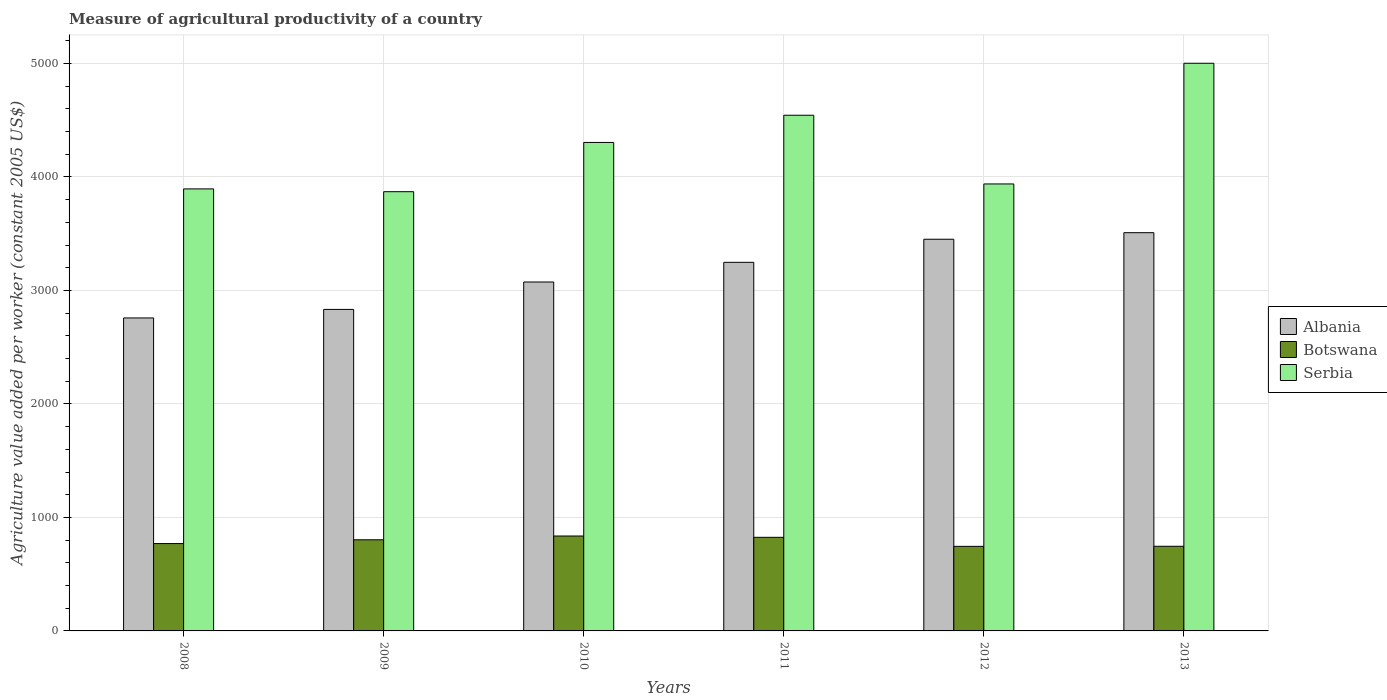How many different coloured bars are there?
Give a very brief answer. 3. How many groups of bars are there?
Provide a succinct answer. 6. Are the number of bars per tick equal to the number of legend labels?
Your answer should be very brief. Yes. How many bars are there on the 4th tick from the right?
Make the answer very short. 3. What is the label of the 2nd group of bars from the left?
Your response must be concise. 2009. What is the measure of agricultural productivity in Botswana in 2008?
Keep it short and to the point. 769.66. Across all years, what is the maximum measure of agricultural productivity in Botswana?
Your answer should be very brief. 836.26. Across all years, what is the minimum measure of agricultural productivity in Botswana?
Your response must be concise. 745.1. What is the total measure of agricultural productivity in Serbia in the graph?
Your response must be concise. 2.56e+04. What is the difference between the measure of agricultural productivity in Albania in 2009 and that in 2013?
Your answer should be compact. -676.02. What is the difference between the measure of agricultural productivity in Serbia in 2011 and the measure of agricultural productivity in Albania in 2013?
Give a very brief answer. 1034.83. What is the average measure of agricultural productivity in Botswana per year?
Provide a short and direct response. 787.42. In the year 2011, what is the difference between the measure of agricultural productivity in Albania and measure of agricultural productivity in Serbia?
Offer a very short reply. -1296.13. In how many years, is the measure of agricultural productivity in Botswana greater than 3000 US$?
Keep it short and to the point. 0. What is the ratio of the measure of agricultural productivity in Albania in 2011 to that in 2012?
Your answer should be very brief. 0.94. Is the difference between the measure of agricultural productivity in Albania in 2009 and 2013 greater than the difference between the measure of agricultural productivity in Serbia in 2009 and 2013?
Make the answer very short. Yes. What is the difference between the highest and the second highest measure of agricultural productivity in Serbia?
Offer a terse response. 457.96. What is the difference between the highest and the lowest measure of agricultural productivity in Botswana?
Give a very brief answer. 91.16. Is the sum of the measure of agricultural productivity in Albania in 2012 and 2013 greater than the maximum measure of agricultural productivity in Serbia across all years?
Give a very brief answer. Yes. What does the 2nd bar from the left in 2012 represents?
Keep it short and to the point. Botswana. What does the 3rd bar from the right in 2011 represents?
Your answer should be very brief. Albania. How many bars are there?
Provide a succinct answer. 18. How many years are there in the graph?
Ensure brevity in your answer.  6. Are the values on the major ticks of Y-axis written in scientific E-notation?
Ensure brevity in your answer.  No. Does the graph contain any zero values?
Ensure brevity in your answer.  No. Does the graph contain grids?
Provide a succinct answer. Yes. Where does the legend appear in the graph?
Give a very brief answer. Center right. How many legend labels are there?
Your answer should be very brief. 3. What is the title of the graph?
Your response must be concise. Measure of agricultural productivity of a country. What is the label or title of the Y-axis?
Your answer should be very brief. Agriculture value added per worker (constant 2005 US$). What is the Agriculture value added per worker (constant 2005 US$) in Albania in 2008?
Your answer should be compact. 2757.6. What is the Agriculture value added per worker (constant 2005 US$) in Botswana in 2008?
Make the answer very short. 769.66. What is the Agriculture value added per worker (constant 2005 US$) in Serbia in 2008?
Your response must be concise. 3894.62. What is the Agriculture value added per worker (constant 2005 US$) of Albania in 2009?
Provide a short and direct response. 2832.81. What is the Agriculture value added per worker (constant 2005 US$) in Botswana in 2009?
Your answer should be compact. 802.96. What is the Agriculture value added per worker (constant 2005 US$) of Serbia in 2009?
Provide a short and direct response. 3870.01. What is the Agriculture value added per worker (constant 2005 US$) of Albania in 2010?
Keep it short and to the point. 3074.35. What is the Agriculture value added per worker (constant 2005 US$) of Botswana in 2010?
Your response must be concise. 836.26. What is the Agriculture value added per worker (constant 2005 US$) in Serbia in 2010?
Your answer should be very brief. 4303.98. What is the Agriculture value added per worker (constant 2005 US$) in Albania in 2011?
Make the answer very short. 3247.53. What is the Agriculture value added per worker (constant 2005 US$) in Botswana in 2011?
Keep it short and to the point. 824.72. What is the Agriculture value added per worker (constant 2005 US$) of Serbia in 2011?
Offer a very short reply. 4543.67. What is the Agriculture value added per worker (constant 2005 US$) in Albania in 2012?
Keep it short and to the point. 3451. What is the Agriculture value added per worker (constant 2005 US$) in Botswana in 2012?
Your response must be concise. 745.1. What is the Agriculture value added per worker (constant 2005 US$) in Serbia in 2012?
Keep it short and to the point. 3938.29. What is the Agriculture value added per worker (constant 2005 US$) of Albania in 2013?
Your answer should be compact. 3508.83. What is the Agriculture value added per worker (constant 2005 US$) in Botswana in 2013?
Provide a short and direct response. 745.83. What is the Agriculture value added per worker (constant 2005 US$) in Serbia in 2013?
Give a very brief answer. 5001.63. Across all years, what is the maximum Agriculture value added per worker (constant 2005 US$) in Albania?
Provide a succinct answer. 3508.83. Across all years, what is the maximum Agriculture value added per worker (constant 2005 US$) in Botswana?
Offer a terse response. 836.26. Across all years, what is the maximum Agriculture value added per worker (constant 2005 US$) of Serbia?
Give a very brief answer. 5001.63. Across all years, what is the minimum Agriculture value added per worker (constant 2005 US$) in Albania?
Make the answer very short. 2757.6. Across all years, what is the minimum Agriculture value added per worker (constant 2005 US$) in Botswana?
Your answer should be very brief. 745.1. Across all years, what is the minimum Agriculture value added per worker (constant 2005 US$) in Serbia?
Your answer should be compact. 3870.01. What is the total Agriculture value added per worker (constant 2005 US$) of Albania in the graph?
Offer a very short reply. 1.89e+04. What is the total Agriculture value added per worker (constant 2005 US$) of Botswana in the graph?
Provide a short and direct response. 4724.53. What is the total Agriculture value added per worker (constant 2005 US$) of Serbia in the graph?
Your answer should be very brief. 2.56e+04. What is the difference between the Agriculture value added per worker (constant 2005 US$) in Albania in 2008 and that in 2009?
Offer a very short reply. -75.21. What is the difference between the Agriculture value added per worker (constant 2005 US$) in Botswana in 2008 and that in 2009?
Offer a terse response. -33.3. What is the difference between the Agriculture value added per worker (constant 2005 US$) of Serbia in 2008 and that in 2009?
Provide a short and direct response. 24.6. What is the difference between the Agriculture value added per worker (constant 2005 US$) of Albania in 2008 and that in 2010?
Your answer should be very brief. -316.75. What is the difference between the Agriculture value added per worker (constant 2005 US$) in Botswana in 2008 and that in 2010?
Give a very brief answer. -66.61. What is the difference between the Agriculture value added per worker (constant 2005 US$) of Serbia in 2008 and that in 2010?
Give a very brief answer. -409.36. What is the difference between the Agriculture value added per worker (constant 2005 US$) of Albania in 2008 and that in 2011?
Your answer should be very brief. -489.94. What is the difference between the Agriculture value added per worker (constant 2005 US$) in Botswana in 2008 and that in 2011?
Make the answer very short. -55.06. What is the difference between the Agriculture value added per worker (constant 2005 US$) in Serbia in 2008 and that in 2011?
Your answer should be very brief. -649.05. What is the difference between the Agriculture value added per worker (constant 2005 US$) of Albania in 2008 and that in 2012?
Ensure brevity in your answer.  -693.4. What is the difference between the Agriculture value added per worker (constant 2005 US$) in Botswana in 2008 and that in 2012?
Ensure brevity in your answer.  24.56. What is the difference between the Agriculture value added per worker (constant 2005 US$) of Serbia in 2008 and that in 2012?
Make the answer very short. -43.67. What is the difference between the Agriculture value added per worker (constant 2005 US$) in Albania in 2008 and that in 2013?
Ensure brevity in your answer.  -751.24. What is the difference between the Agriculture value added per worker (constant 2005 US$) of Botswana in 2008 and that in 2013?
Provide a succinct answer. 23.82. What is the difference between the Agriculture value added per worker (constant 2005 US$) of Serbia in 2008 and that in 2013?
Provide a succinct answer. -1107.01. What is the difference between the Agriculture value added per worker (constant 2005 US$) in Albania in 2009 and that in 2010?
Offer a terse response. -241.54. What is the difference between the Agriculture value added per worker (constant 2005 US$) in Botswana in 2009 and that in 2010?
Give a very brief answer. -33.3. What is the difference between the Agriculture value added per worker (constant 2005 US$) in Serbia in 2009 and that in 2010?
Ensure brevity in your answer.  -433.96. What is the difference between the Agriculture value added per worker (constant 2005 US$) of Albania in 2009 and that in 2011?
Provide a succinct answer. -414.72. What is the difference between the Agriculture value added per worker (constant 2005 US$) in Botswana in 2009 and that in 2011?
Your response must be concise. -21.76. What is the difference between the Agriculture value added per worker (constant 2005 US$) in Serbia in 2009 and that in 2011?
Provide a succinct answer. -673.66. What is the difference between the Agriculture value added per worker (constant 2005 US$) of Albania in 2009 and that in 2012?
Give a very brief answer. -618.18. What is the difference between the Agriculture value added per worker (constant 2005 US$) of Botswana in 2009 and that in 2012?
Give a very brief answer. 57.86. What is the difference between the Agriculture value added per worker (constant 2005 US$) of Serbia in 2009 and that in 2012?
Your response must be concise. -68.27. What is the difference between the Agriculture value added per worker (constant 2005 US$) in Albania in 2009 and that in 2013?
Offer a very short reply. -676.02. What is the difference between the Agriculture value added per worker (constant 2005 US$) of Botswana in 2009 and that in 2013?
Your answer should be compact. 57.12. What is the difference between the Agriculture value added per worker (constant 2005 US$) of Serbia in 2009 and that in 2013?
Your answer should be compact. -1131.61. What is the difference between the Agriculture value added per worker (constant 2005 US$) in Albania in 2010 and that in 2011?
Your answer should be very brief. -173.19. What is the difference between the Agriculture value added per worker (constant 2005 US$) in Botswana in 2010 and that in 2011?
Your response must be concise. 11.54. What is the difference between the Agriculture value added per worker (constant 2005 US$) in Serbia in 2010 and that in 2011?
Keep it short and to the point. -239.69. What is the difference between the Agriculture value added per worker (constant 2005 US$) of Albania in 2010 and that in 2012?
Your answer should be very brief. -376.65. What is the difference between the Agriculture value added per worker (constant 2005 US$) of Botswana in 2010 and that in 2012?
Ensure brevity in your answer.  91.17. What is the difference between the Agriculture value added per worker (constant 2005 US$) in Serbia in 2010 and that in 2012?
Your response must be concise. 365.69. What is the difference between the Agriculture value added per worker (constant 2005 US$) in Albania in 2010 and that in 2013?
Provide a short and direct response. -434.48. What is the difference between the Agriculture value added per worker (constant 2005 US$) of Botswana in 2010 and that in 2013?
Your answer should be compact. 90.43. What is the difference between the Agriculture value added per worker (constant 2005 US$) in Serbia in 2010 and that in 2013?
Your response must be concise. -697.65. What is the difference between the Agriculture value added per worker (constant 2005 US$) of Albania in 2011 and that in 2012?
Keep it short and to the point. -203.46. What is the difference between the Agriculture value added per worker (constant 2005 US$) of Botswana in 2011 and that in 2012?
Make the answer very short. 79.62. What is the difference between the Agriculture value added per worker (constant 2005 US$) of Serbia in 2011 and that in 2012?
Your answer should be very brief. 605.38. What is the difference between the Agriculture value added per worker (constant 2005 US$) of Albania in 2011 and that in 2013?
Provide a succinct answer. -261.3. What is the difference between the Agriculture value added per worker (constant 2005 US$) in Botswana in 2011 and that in 2013?
Provide a short and direct response. 78.88. What is the difference between the Agriculture value added per worker (constant 2005 US$) in Serbia in 2011 and that in 2013?
Your answer should be compact. -457.96. What is the difference between the Agriculture value added per worker (constant 2005 US$) in Albania in 2012 and that in 2013?
Your answer should be compact. -57.84. What is the difference between the Agriculture value added per worker (constant 2005 US$) in Botswana in 2012 and that in 2013?
Provide a short and direct response. -0.74. What is the difference between the Agriculture value added per worker (constant 2005 US$) in Serbia in 2012 and that in 2013?
Give a very brief answer. -1063.34. What is the difference between the Agriculture value added per worker (constant 2005 US$) in Albania in 2008 and the Agriculture value added per worker (constant 2005 US$) in Botswana in 2009?
Give a very brief answer. 1954.64. What is the difference between the Agriculture value added per worker (constant 2005 US$) in Albania in 2008 and the Agriculture value added per worker (constant 2005 US$) in Serbia in 2009?
Make the answer very short. -1112.41. What is the difference between the Agriculture value added per worker (constant 2005 US$) of Botswana in 2008 and the Agriculture value added per worker (constant 2005 US$) of Serbia in 2009?
Make the answer very short. -3100.35. What is the difference between the Agriculture value added per worker (constant 2005 US$) in Albania in 2008 and the Agriculture value added per worker (constant 2005 US$) in Botswana in 2010?
Ensure brevity in your answer.  1921.34. What is the difference between the Agriculture value added per worker (constant 2005 US$) of Albania in 2008 and the Agriculture value added per worker (constant 2005 US$) of Serbia in 2010?
Keep it short and to the point. -1546.38. What is the difference between the Agriculture value added per worker (constant 2005 US$) in Botswana in 2008 and the Agriculture value added per worker (constant 2005 US$) in Serbia in 2010?
Ensure brevity in your answer.  -3534.32. What is the difference between the Agriculture value added per worker (constant 2005 US$) in Albania in 2008 and the Agriculture value added per worker (constant 2005 US$) in Botswana in 2011?
Your answer should be compact. 1932.88. What is the difference between the Agriculture value added per worker (constant 2005 US$) of Albania in 2008 and the Agriculture value added per worker (constant 2005 US$) of Serbia in 2011?
Offer a very short reply. -1786.07. What is the difference between the Agriculture value added per worker (constant 2005 US$) of Botswana in 2008 and the Agriculture value added per worker (constant 2005 US$) of Serbia in 2011?
Give a very brief answer. -3774.01. What is the difference between the Agriculture value added per worker (constant 2005 US$) of Albania in 2008 and the Agriculture value added per worker (constant 2005 US$) of Botswana in 2012?
Offer a terse response. 2012.5. What is the difference between the Agriculture value added per worker (constant 2005 US$) in Albania in 2008 and the Agriculture value added per worker (constant 2005 US$) in Serbia in 2012?
Offer a very short reply. -1180.69. What is the difference between the Agriculture value added per worker (constant 2005 US$) of Botswana in 2008 and the Agriculture value added per worker (constant 2005 US$) of Serbia in 2012?
Your response must be concise. -3168.63. What is the difference between the Agriculture value added per worker (constant 2005 US$) of Albania in 2008 and the Agriculture value added per worker (constant 2005 US$) of Botswana in 2013?
Offer a terse response. 2011.76. What is the difference between the Agriculture value added per worker (constant 2005 US$) of Albania in 2008 and the Agriculture value added per worker (constant 2005 US$) of Serbia in 2013?
Provide a succinct answer. -2244.03. What is the difference between the Agriculture value added per worker (constant 2005 US$) of Botswana in 2008 and the Agriculture value added per worker (constant 2005 US$) of Serbia in 2013?
Ensure brevity in your answer.  -4231.97. What is the difference between the Agriculture value added per worker (constant 2005 US$) of Albania in 2009 and the Agriculture value added per worker (constant 2005 US$) of Botswana in 2010?
Keep it short and to the point. 1996.55. What is the difference between the Agriculture value added per worker (constant 2005 US$) in Albania in 2009 and the Agriculture value added per worker (constant 2005 US$) in Serbia in 2010?
Your response must be concise. -1471.16. What is the difference between the Agriculture value added per worker (constant 2005 US$) of Botswana in 2009 and the Agriculture value added per worker (constant 2005 US$) of Serbia in 2010?
Offer a terse response. -3501.02. What is the difference between the Agriculture value added per worker (constant 2005 US$) in Albania in 2009 and the Agriculture value added per worker (constant 2005 US$) in Botswana in 2011?
Give a very brief answer. 2008.09. What is the difference between the Agriculture value added per worker (constant 2005 US$) in Albania in 2009 and the Agriculture value added per worker (constant 2005 US$) in Serbia in 2011?
Make the answer very short. -1710.85. What is the difference between the Agriculture value added per worker (constant 2005 US$) in Botswana in 2009 and the Agriculture value added per worker (constant 2005 US$) in Serbia in 2011?
Provide a succinct answer. -3740.71. What is the difference between the Agriculture value added per worker (constant 2005 US$) in Albania in 2009 and the Agriculture value added per worker (constant 2005 US$) in Botswana in 2012?
Your answer should be compact. 2087.72. What is the difference between the Agriculture value added per worker (constant 2005 US$) of Albania in 2009 and the Agriculture value added per worker (constant 2005 US$) of Serbia in 2012?
Offer a very short reply. -1105.47. What is the difference between the Agriculture value added per worker (constant 2005 US$) in Botswana in 2009 and the Agriculture value added per worker (constant 2005 US$) in Serbia in 2012?
Keep it short and to the point. -3135.33. What is the difference between the Agriculture value added per worker (constant 2005 US$) of Albania in 2009 and the Agriculture value added per worker (constant 2005 US$) of Botswana in 2013?
Your answer should be very brief. 2086.98. What is the difference between the Agriculture value added per worker (constant 2005 US$) in Albania in 2009 and the Agriculture value added per worker (constant 2005 US$) in Serbia in 2013?
Offer a very short reply. -2168.81. What is the difference between the Agriculture value added per worker (constant 2005 US$) in Botswana in 2009 and the Agriculture value added per worker (constant 2005 US$) in Serbia in 2013?
Your answer should be very brief. -4198.67. What is the difference between the Agriculture value added per worker (constant 2005 US$) in Albania in 2010 and the Agriculture value added per worker (constant 2005 US$) in Botswana in 2011?
Your answer should be very brief. 2249.63. What is the difference between the Agriculture value added per worker (constant 2005 US$) in Albania in 2010 and the Agriculture value added per worker (constant 2005 US$) in Serbia in 2011?
Keep it short and to the point. -1469.32. What is the difference between the Agriculture value added per worker (constant 2005 US$) in Botswana in 2010 and the Agriculture value added per worker (constant 2005 US$) in Serbia in 2011?
Ensure brevity in your answer.  -3707.4. What is the difference between the Agriculture value added per worker (constant 2005 US$) in Albania in 2010 and the Agriculture value added per worker (constant 2005 US$) in Botswana in 2012?
Ensure brevity in your answer.  2329.25. What is the difference between the Agriculture value added per worker (constant 2005 US$) in Albania in 2010 and the Agriculture value added per worker (constant 2005 US$) in Serbia in 2012?
Offer a very short reply. -863.94. What is the difference between the Agriculture value added per worker (constant 2005 US$) of Botswana in 2010 and the Agriculture value added per worker (constant 2005 US$) of Serbia in 2012?
Provide a succinct answer. -3102.02. What is the difference between the Agriculture value added per worker (constant 2005 US$) in Albania in 2010 and the Agriculture value added per worker (constant 2005 US$) in Botswana in 2013?
Your response must be concise. 2328.51. What is the difference between the Agriculture value added per worker (constant 2005 US$) in Albania in 2010 and the Agriculture value added per worker (constant 2005 US$) in Serbia in 2013?
Offer a terse response. -1927.28. What is the difference between the Agriculture value added per worker (constant 2005 US$) in Botswana in 2010 and the Agriculture value added per worker (constant 2005 US$) in Serbia in 2013?
Ensure brevity in your answer.  -4165.36. What is the difference between the Agriculture value added per worker (constant 2005 US$) of Albania in 2011 and the Agriculture value added per worker (constant 2005 US$) of Botswana in 2012?
Offer a very short reply. 2502.44. What is the difference between the Agriculture value added per worker (constant 2005 US$) in Albania in 2011 and the Agriculture value added per worker (constant 2005 US$) in Serbia in 2012?
Keep it short and to the point. -690.75. What is the difference between the Agriculture value added per worker (constant 2005 US$) of Botswana in 2011 and the Agriculture value added per worker (constant 2005 US$) of Serbia in 2012?
Provide a short and direct response. -3113.57. What is the difference between the Agriculture value added per worker (constant 2005 US$) in Albania in 2011 and the Agriculture value added per worker (constant 2005 US$) in Botswana in 2013?
Ensure brevity in your answer.  2501.7. What is the difference between the Agriculture value added per worker (constant 2005 US$) of Albania in 2011 and the Agriculture value added per worker (constant 2005 US$) of Serbia in 2013?
Provide a succinct answer. -1754.09. What is the difference between the Agriculture value added per worker (constant 2005 US$) of Botswana in 2011 and the Agriculture value added per worker (constant 2005 US$) of Serbia in 2013?
Offer a very short reply. -4176.91. What is the difference between the Agriculture value added per worker (constant 2005 US$) in Albania in 2012 and the Agriculture value added per worker (constant 2005 US$) in Botswana in 2013?
Provide a succinct answer. 2705.16. What is the difference between the Agriculture value added per worker (constant 2005 US$) in Albania in 2012 and the Agriculture value added per worker (constant 2005 US$) in Serbia in 2013?
Your answer should be compact. -1550.63. What is the difference between the Agriculture value added per worker (constant 2005 US$) in Botswana in 2012 and the Agriculture value added per worker (constant 2005 US$) in Serbia in 2013?
Give a very brief answer. -4256.53. What is the average Agriculture value added per worker (constant 2005 US$) of Albania per year?
Your answer should be compact. 3145.35. What is the average Agriculture value added per worker (constant 2005 US$) in Botswana per year?
Provide a short and direct response. 787.42. What is the average Agriculture value added per worker (constant 2005 US$) of Serbia per year?
Provide a succinct answer. 4258.7. In the year 2008, what is the difference between the Agriculture value added per worker (constant 2005 US$) in Albania and Agriculture value added per worker (constant 2005 US$) in Botswana?
Offer a very short reply. 1987.94. In the year 2008, what is the difference between the Agriculture value added per worker (constant 2005 US$) of Albania and Agriculture value added per worker (constant 2005 US$) of Serbia?
Your answer should be very brief. -1137.02. In the year 2008, what is the difference between the Agriculture value added per worker (constant 2005 US$) in Botswana and Agriculture value added per worker (constant 2005 US$) in Serbia?
Make the answer very short. -3124.96. In the year 2009, what is the difference between the Agriculture value added per worker (constant 2005 US$) in Albania and Agriculture value added per worker (constant 2005 US$) in Botswana?
Make the answer very short. 2029.85. In the year 2009, what is the difference between the Agriculture value added per worker (constant 2005 US$) of Albania and Agriculture value added per worker (constant 2005 US$) of Serbia?
Make the answer very short. -1037.2. In the year 2009, what is the difference between the Agriculture value added per worker (constant 2005 US$) of Botswana and Agriculture value added per worker (constant 2005 US$) of Serbia?
Your response must be concise. -3067.05. In the year 2010, what is the difference between the Agriculture value added per worker (constant 2005 US$) of Albania and Agriculture value added per worker (constant 2005 US$) of Botswana?
Give a very brief answer. 2238.09. In the year 2010, what is the difference between the Agriculture value added per worker (constant 2005 US$) in Albania and Agriculture value added per worker (constant 2005 US$) in Serbia?
Give a very brief answer. -1229.63. In the year 2010, what is the difference between the Agriculture value added per worker (constant 2005 US$) of Botswana and Agriculture value added per worker (constant 2005 US$) of Serbia?
Your answer should be compact. -3467.71. In the year 2011, what is the difference between the Agriculture value added per worker (constant 2005 US$) in Albania and Agriculture value added per worker (constant 2005 US$) in Botswana?
Your answer should be very brief. 2422.82. In the year 2011, what is the difference between the Agriculture value added per worker (constant 2005 US$) in Albania and Agriculture value added per worker (constant 2005 US$) in Serbia?
Provide a short and direct response. -1296.13. In the year 2011, what is the difference between the Agriculture value added per worker (constant 2005 US$) of Botswana and Agriculture value added per worker (constant 2005 US$) of Serbia?
Offer a very short reply. -3718.95. In the year 2012, what is the difference between the Agriculture value added per worker (constant 2005 US$) in Albania and Agriculture value added per worker (constant 2005 US$) in Botswana?
Offer a very short reply. 2705.9. In the year 2012, what is the difference between the Agriculture value added per worker (constant 2005 US$) of Albania and Agriculture value added per worker (constant 2005 US$) of Serbia?
Your answer should be very brief. -487.29. In the year 2012, what is the difference between the Agriculture value added per worker (constant 2005 US$) in Botswana and Agriculture value added per worker (constant 2005 US$) in Serbia?
Give a very brief answer. -3193.19. In the year 2013, what is the difference between the Agriculture value added per worker (constant 2005 US$) in Albania and Agriculture value added per worker (constant 2005 US$) in Botswana?
Offer a very short reply. 2763. In the year 2013, what is the difference between the Agriculture value added per worker (constant 2005 US$) of Albania and Agriculture value added per worker (constant 2005 US$) of Serbia?
Offer a very short reply. -1492.79. In the year 2013, what is the difference between the Agriculture value added per worker (constant 2005 US$) of Botswana and Agriculture value added per worker (constant 2005 US$) of Serbia?
Ensure brevity in your answer.  -4255.79. What is the ratio of the Agriculture value added per worker (constant 2005 US$) in Albania in 2008 to that in 2009?
Your response must be concise. 0.97. What is the ratio of the Agriculture value added per worker (constant 2005 US$) in Botswana in 2008 to that in 2009?
Provide a short and direct response. 0.96. What is the ratio of the Agriculture value added per worker (constant 2005 US$) in Serbia in 2008 to that in 2009?
Ensure brevity in your answer.  1.01. What is the ratio of the Agriculture value added per worker (constant 2005 US$) of Albania in 2008 to that in 2010?
Offer a very short reply. 0.9. What is the ratio of the Agriculture value added per worker (constant 2005 US$) in Botswana in 2008 to that in 2010?
Your answer should be compact. 0.92. What is the ratio of the Agriculture value added per worker (constant 2005 US$) of Serbia in 2008 to that in 2010?
Offer a very short reply. 0.9. What is the ratio of the Agriculture value added per worker (constant 2005 US$) of Albania in 2008 to that in 2011?
Your answer should be very brief. 0.85. What is the ratio of the Agriculture value added per worker (constant 2005 US$) in Botswana in 2008 to that in 2011?
Your answer should be very brief. 0.93. What is the ratio of the Agriculture value added per worker (constant 2005 US$) of Serbia in 2008 to that in 2011?
Offer a very short reply. 0.86. What is the ratio of the Agriculture value added per worker (constant 2005 US$) in Albania in 2008 to that in 2012?
Offer a very short reply. 0.8. What is the ratio of the Agriculture value added per worker (constant 2005 US$) in Botswana in 2008 to that in 2012?
Offer a very short reply. 1.03. What is the ratio of the Agriculture value added per worker (constant 2005 US$) in Serbia in 2008 to that in 2012?
Your answer should be compact. 0.99. What is the ratio of the Agriculture value added per worker (constant 2005 US$) in Albania in 2008 to that in 2013?
Ensure brevity in your answer.  0.79. What is the ratio of the Agriculture value added per worker (constant 2005 US$) in Botswana in 2008 to that in 2013?
Provide a short and direct response. 1.03. What is the ratio of the Agriculture value added per worker (constant 2005 US$) in Serbia in 2008 to that in 2013?
Make the answer very short. 0.78. What is the ratio of the Agriculture value added per worker (constant 2005 US$) of Albania in 2009 to that in 2010?
Ensure brevity in your answer.  0.92. What is the ratio of the Agriculture value added per worker (constant 2005 US$) in Botswana in 2009 to that in 2010?
Offer a very short reply. 0.96. What is the ratio of the Agriculture value added per worker (constant 2005 US$) of Serbia in 2009 to that in 2010?
Offer a terse response. 0.9. What is the ratio of the Agriculture value added per worker (constant 2005 US$) of Albania in 2009 to that in 2011?
Provide a short and direct response. 0.87. What is the ratio of the Agriculture value added per worker (constant 2005 US$) in Botswana in 2009 to that in 2011?
Keep it short and to the point. 0.97. What is the ratio of the Agriculture value added per worker (constant 2005 US$) in Serbia in 2009 to that in 2011?
Offer a very short reply. 0.85. What is the ratio of the Agriculture value added per worker (constant 2005 US$) in Albania in 2009 to that in 2012?
Offer a terse response. 0.82. What is the ratio of the Agriculture value added per worker (constant 2005 US$) of Botswana in 2009 to that in 2012?
Keep it short and to the point. 1.08. What is the ratio of the Agriculture value added per worker (constant 2005 US$) of Serbia in 2009 to that in 2012?
Offer a very short reply. 0.98. What is the ratio of the Agriculture value added per worker (constant 2005 US$) in Albania in 2009 to that in 2013?
Your answer should be very brief. 0.81. What is the ratio of the Agriculture value added per worker (constant 2005 US$) in Botswana in 2009 to that in 2013?
Provide a succinct answer. 1.08. What is the ratio of the Agriculture value added per worker (constant 2005 US$) in Serbia in 2009 to that in 2013?
Provide a short and direct response. 0.77. What is the ratio of the Agriculture value added per worker (constant 2005 US$) of Albania in 2010 to that in 2011?
Ensure brevity in your answer.  0.95. What is the ratio of the Agriculture value added per worker (constant 2005 US$) in Botswana in 2010 to that in 2011?
Keep it short and to the point. 1.01. What is the ratio of the Agriculture value added per worker (constant 2005 US$) of Serbia in 2010 to that in 2011?
Ensure brevity in your answer.  0.95. What is the ratio of the Agriculture value added per worker (constant 2005 US$) in Albania in 2010 to that in 2012?
Ensure brevity in your answer.  0.89. What is the ratio of the Agriculture value added per worker (constant 2005 US$) in Botswana in 2010 to that in 2012?
Your answer should be compact. 1.12. What is the ratio of the Agriculture value added per worker (constant 2005 US$) of Serbia in 2010 to that in 2012?
Give a very brief answer. 1.09. What is the ratio of the Agriculture value added per worker (constant 2005 US$) of Albania in 2010 to that in 2013?
Give a very brief answer. 0.88. What is the ratio of the Agriculture value added per worker (constant 2005 US$) in Botswana in 2010 to that in 2013?
Your answer should be compact. 1.12. What is the ratio of the Agriculture value added per worker (constant 2005 US$) in Serbia in 2010 to that in 2013?
Offer a very short reply. 0.86. What is the ratio of the Agriculture value added per worker (constant 2005 US$) in Albania in 2011 to that in 2012?
Offer a very short reply. 0.94. What is the ratio of the Agriculture value added per worker (constant 2005 US$) in Botswana in 2011 to that in 2012?
Keep it short and to the point. 1.11. What is the ratio of the Agriculture value added per worker (constant 2005 US$) of Serbia in 2011 to that in 2012?
Make the answer very short. 1.15. What is the ratio of the Agriculture value added per worker (constant 2005 US$) of Albania in 2011 to that in 2013?
Your response must be concise. 0.93. What is the ratio of the Agriculture value added per worker (constant 2005 US$) of Botswana in 2011 to that in 2013?
Offer a very short reply. 1.11. What is the ratio of the Agriculture value added per worker (constant 2005 US$) in Serbia in 2011 to that in 2013?
Keep it short and to the point. 0.91. What is the ratio of the Agriculture value added per worker (constant 2005 US$) in Albania in 2012 to that in 2013?
Your answer should be very brief. 0.98. What is the ratio of the Agriculture value added per worker (constant 2005 US$) of Botswana in 2012 to that in 2013?
Offer a very short reply. 1. What is the ratio of the Agriculture value added per worker (constant 2005 US$) in Serbia in 2012 to that in 2013?
Your answer should be compact. 0.79. What is the difference between the highest and the second highest Agriculture value added per worker (constant 2005 US$) of Albania?
Your response must be concise. 57.84. What is the difference between the highest and the second highest Agriculture value added per worker (constant 2005 US$) in Botswana?
Provide a succinct answer. 11.54. What is the difference between the highest and the second highest Agriculture value added per worker (constant 2005 US$) of Serbia?
Keep it short and to the point. 457.96. What is the difference between the highest and the lowest Agriculture value added per worker (constant 2005 US$) of Albania?
Provide a succinct answer. 751.24. What is the difference between the highest and the lowest Agriculture value added per worker (constant 2005 US$) of Botswana?
Provide a short and direct response. 91.17. What is the difference between the highest and the lowest Agriculture value added per worker (constant 2005 US$) of Serbia?
Your answer should be compact. 1131.61. 